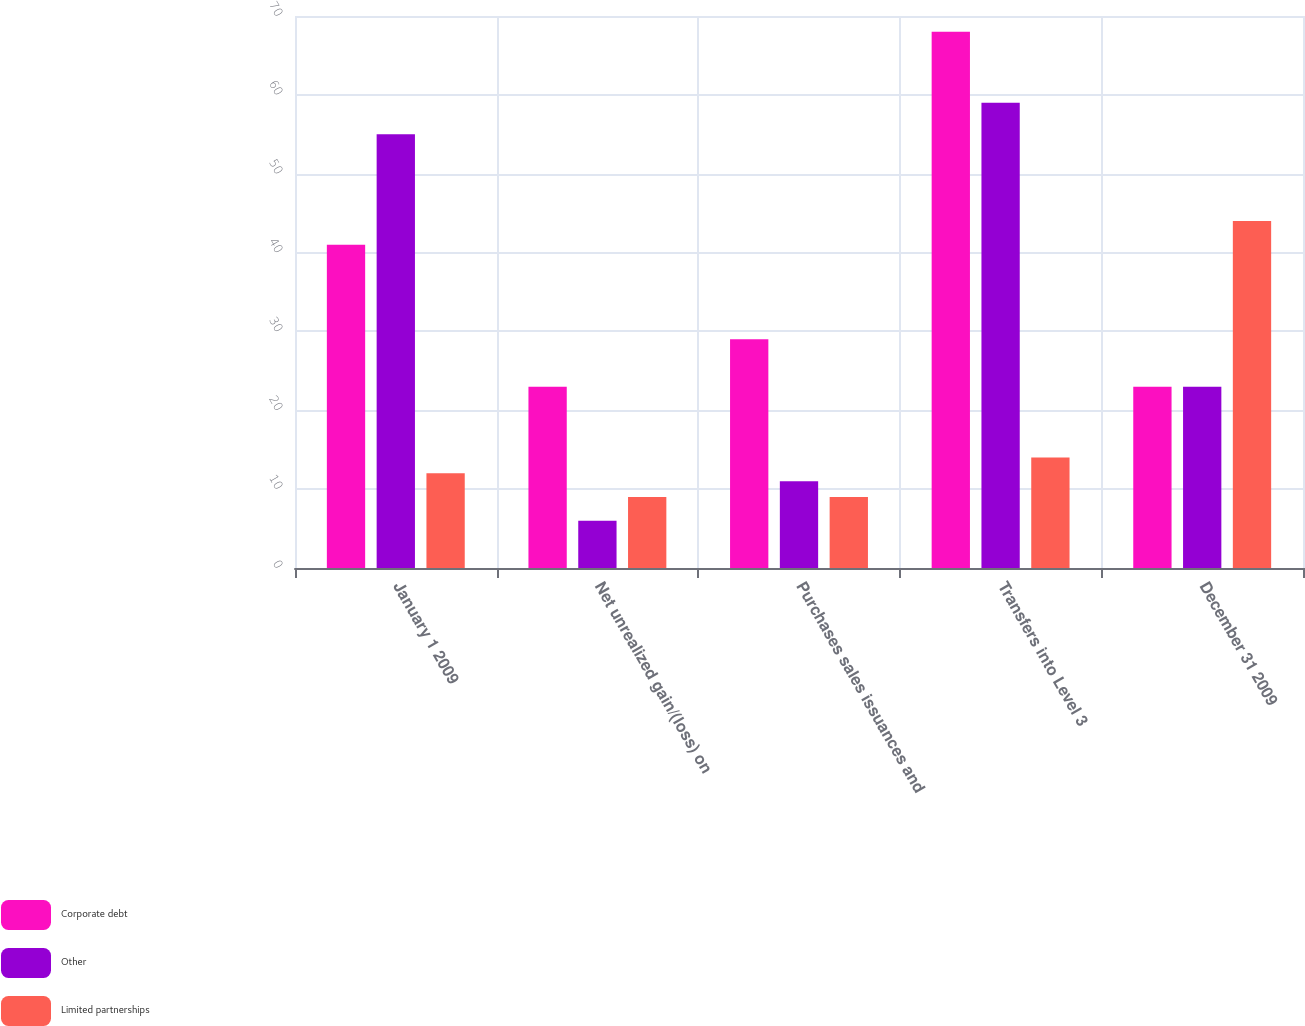Convert chart to OTSL. <chart><loc_0><loc_0><loc_500><loc_500><stacked_bar_chart><ecel><fcel>January 1 2009<fcel>Net unrealized gain/(loss) on<fcel>Purchases sales issuances and<fcel>Transfers into Level 3<fcel>December 31 2009<nl><fcel>Corporate debt<fcel>41<fcel>23<fcel>29<fcel>68<fcel>23<nl><fcel>Other<fcel>55<fcel>6<fcel>11<fcel>59<fcel>23<nl><fcel>Limited partnerships<fcel>12<fcel>9<fcel>9<fcel>14<fcel>44<nl></chart> 